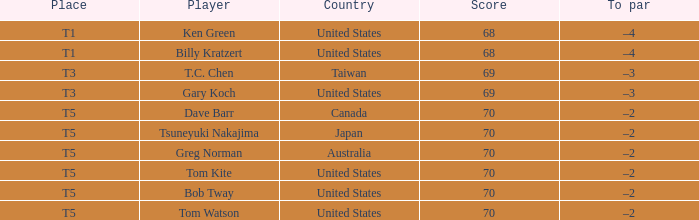What is the lowest score that Bob Tway get when he placed t5? 70.0. 